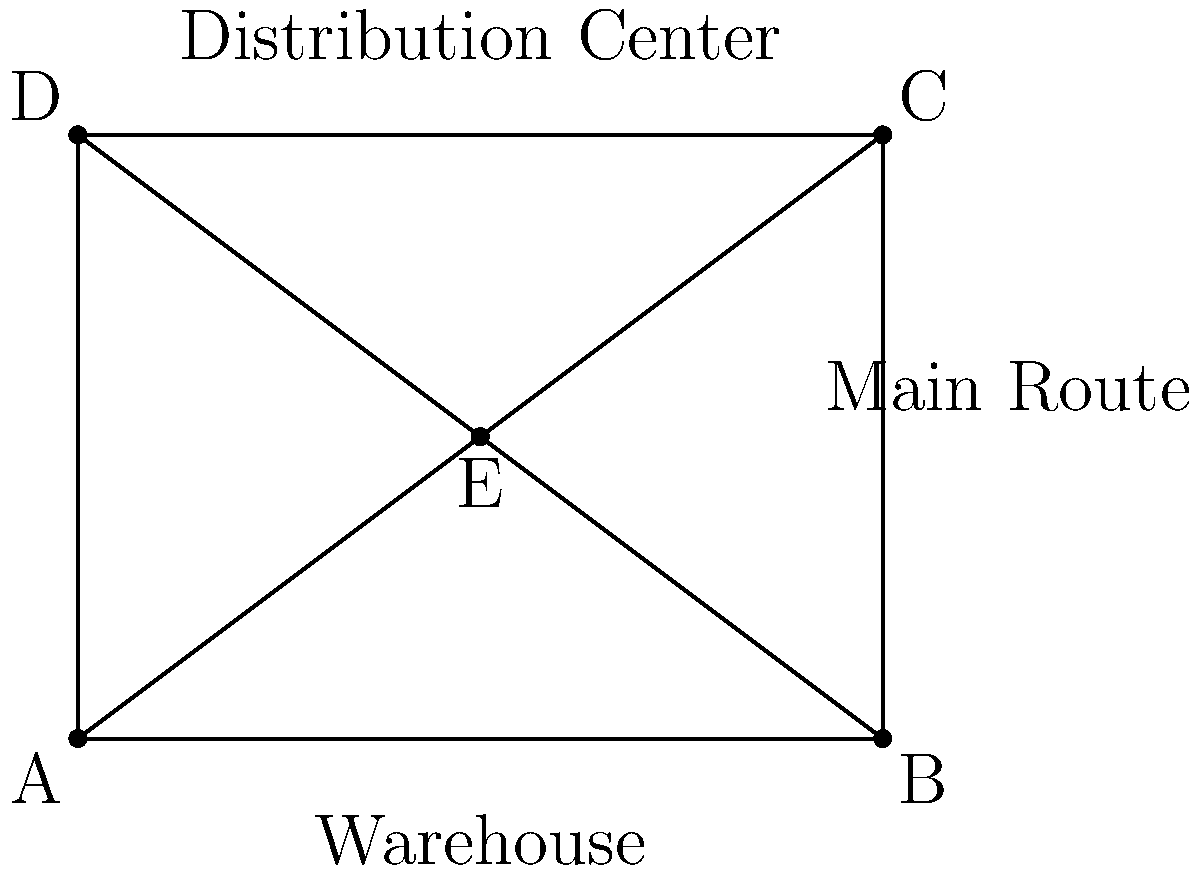A supply chain network diagram is given, showing a warehouse, distribution center, and main delivery route. To optimize delivery routes, the diagram needs to be rotated 90° clockwise around point E. What will be the new coordinates of point C after the rotation? To solve this problem, we'll follow these steps:

1) First, identify the coordinates of points E and C:
   E: (2, 1.5)
   C: (4, 3)

2) To rotate point C around E, we need to:
   a) Translate the coordinate system so that E is at the origin
   b) Perform the rotation
   c) Translate back

3) Translate C so E is at the origin:
   C': (4-2, 3-1.5) = (2, 1.5)

4) For a 90° clockwise rotation, we use the formula:
   $$(x', y') = (y, -x)$$

   So, C'' = (1.5, -2)

5) Translate back:
   C_new = (1.5+2, -2+1.5) = (3.5, -0.5)

Therefore, after rotation, point C will be at (3.5, -0.5).
Answer: (3.5, -0.5) 